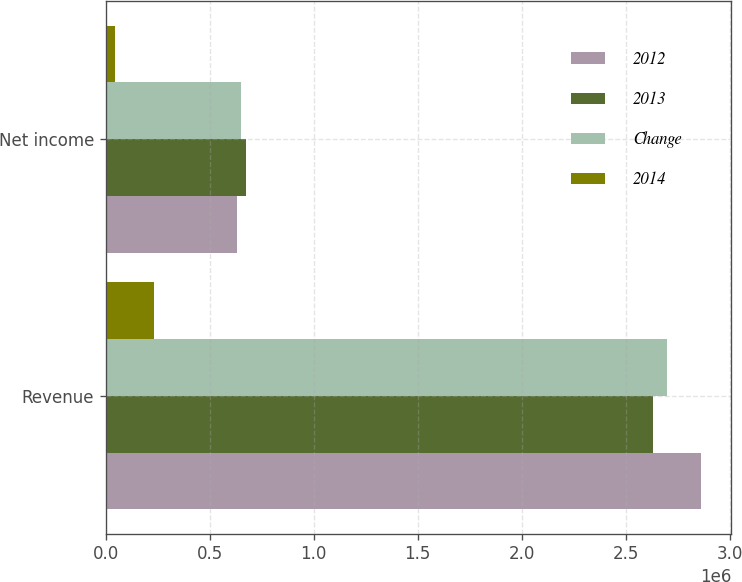Convert chart. <chart><loc_0><loc_0><loc_500><loc_500><stacked_bar_chart><ecel><fcel>Revenue<fcel>Net income<nl><fcel>2012<fcel>2.86477e+06<fcel>629320<nl><fcel>2013<fcel>2.63369e+06<fcel>673487<nl><fcel>Change<fcel>2.70114e+06<fcel>651236<nl><fcel>2014<fcel>231084<fcel>44167<nl></chart> 